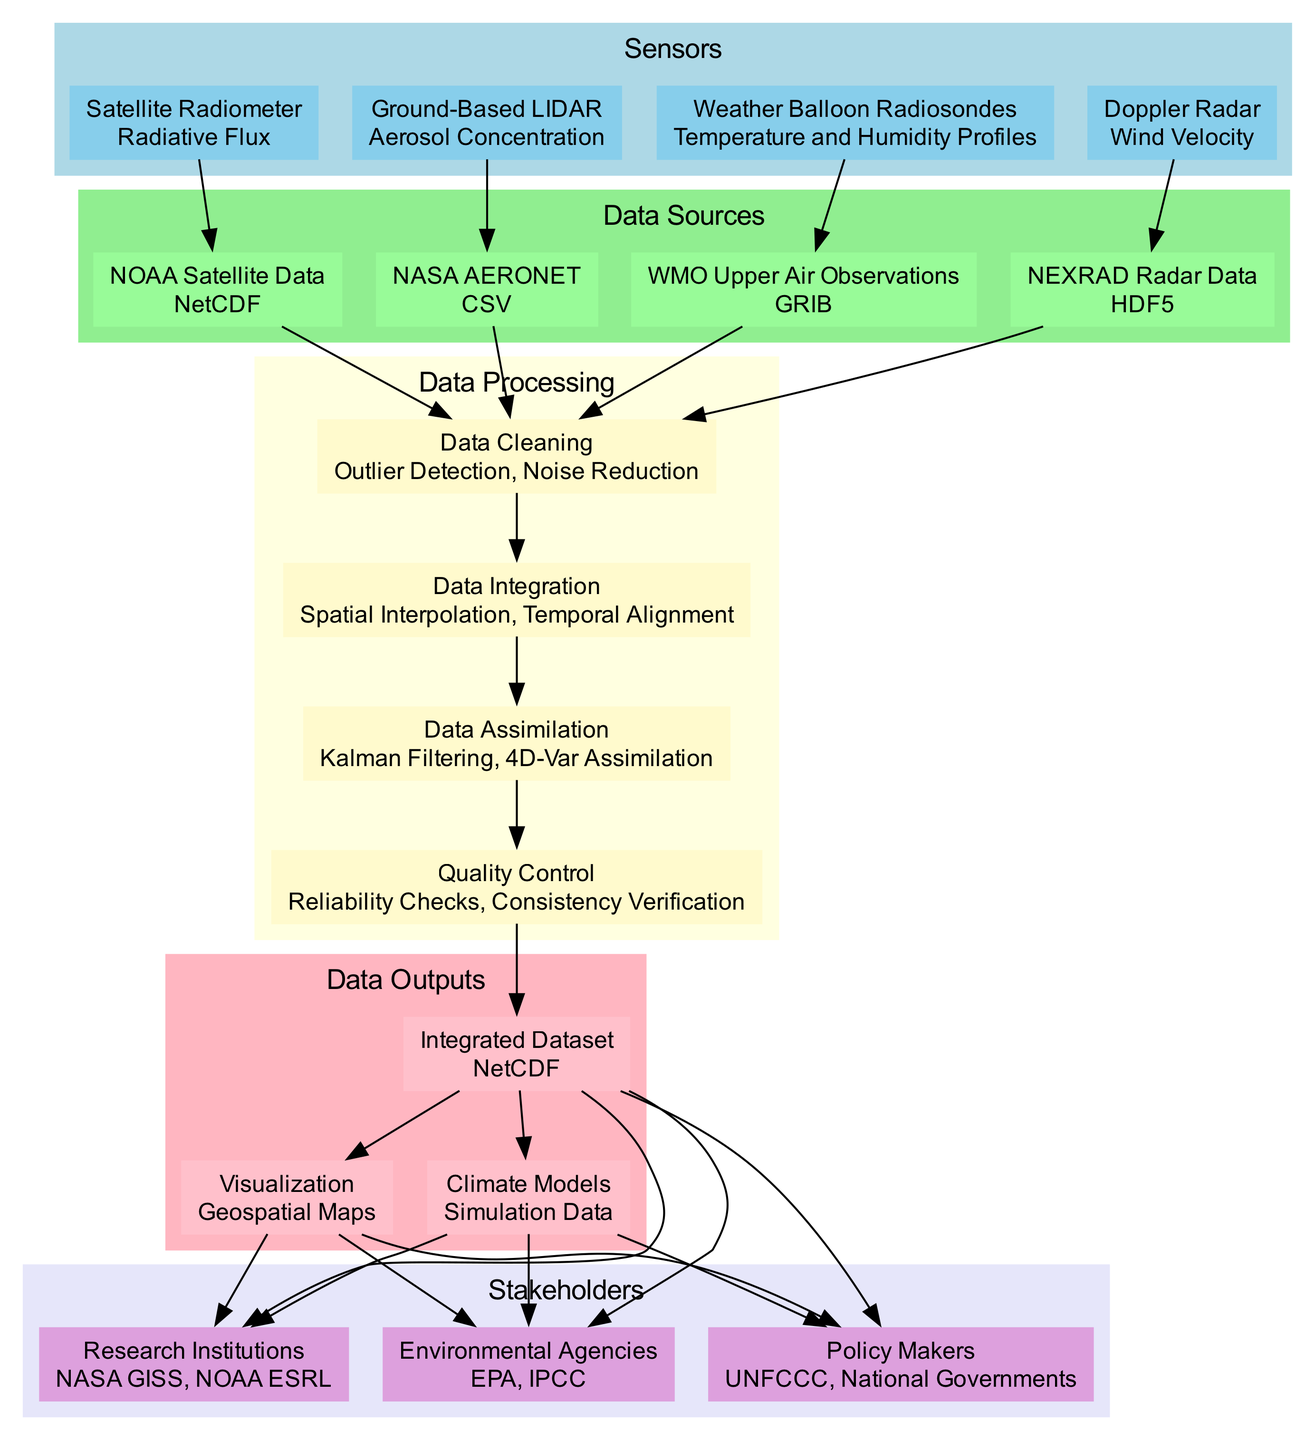What type of sensor is used to measure aerosol concentration? The diagram shows "Ground-Based LIDAR" listed under the "Sensors" section, with its corresponding data type identified as "Aerosol Concentration."
Answer: Ground-Based LIDAR How many different data sources are represented in the diagram? The diagram has a "Data Sources" section showing four distinct entities: NOAA Satellite Data, NASA AERONET, WMO Upper Air Observations, and NEXRAD Radar Data, which totals to four sources.
Answer: 4 What is the frequency of the Wind Velocity measurements? The "Doppler Radar" sensor in the diagram specifies a frequency of "Every 10 Minutes" for its measurements related to Wind Velocity.
Answer: Every 10 Minutes Which data processing method comes after Data Cleaning? According to the flow displayed in the diagram, the node for "Data Cleaning" leads directly to "Data Integration," indicating that Data Integration is the next step in the processing chain.
Answer: Data Integration What are the formats of the outputs produced from the integrated dataset? The output section in the diagram indicates three formats produced: "NetCDF," "Geospatial Maps," and "Simulation Data," thus representing the various output formats stemming from the integrated dataset.
Answer: NetCDF, Geospatial Maps, Simulation Data Which stakeholder is associated with environmental policy? The diagram lists stakeholders, among which "Policy Makers" is highlighted, specifically mentioning entities like "UNFCCC" and "National Governments," denoting their involvement in environmental policy.
Answer: Policy Makers How does data assimilation relate to quality control? Observing the processing steps in the diagram, "Data Assimilation" flows into "Quality Control," indicating that Quality Control is a subsequent step following Data Assimilation in the data processing flow.
Answer: Quality Control What key data attributes does the Integrated Dataset possess? Under the "Data Outputs" section, the "Integrated Dataset" is described with important attributes such as "Radiative Forcing," "Atmospheric Composition Profiles," and "Regional Wind Patterns."
Answer: Radiative Forcing, Atmospheric Composition Profiles, Regional Wind Patterns What type of data does NOAA Satellite Data provide? The diagram states that the "NOAA Satellite Data" source includes attributes like "Radiative Flux," "Sea Surface Temperature," and "Cloud Cover," indicating this is the data provided by this source.
Answer: Radiative Flux, Sea Surface Temperature, Cloud Cover 